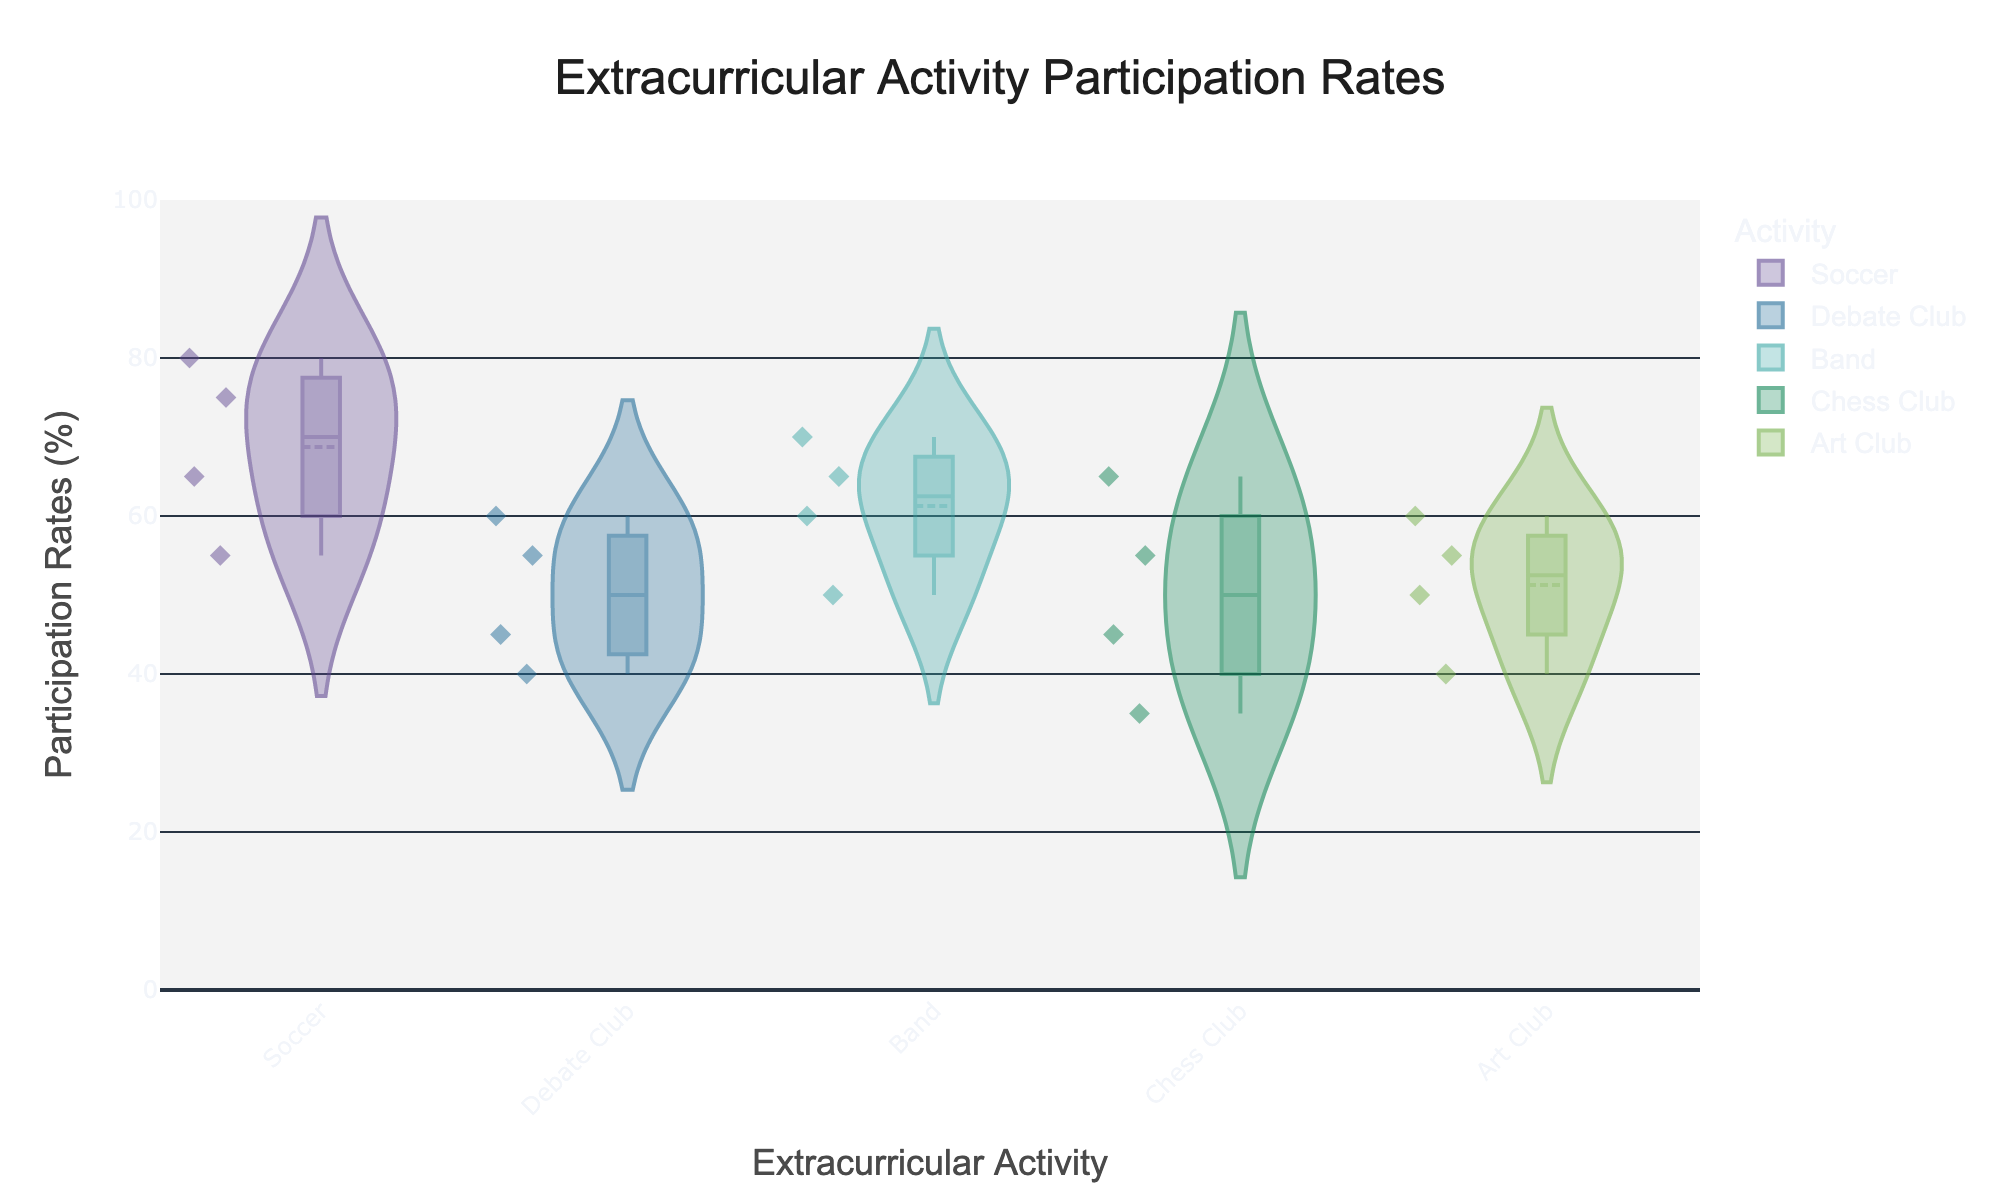What is the title of the figure? The title is usually placed at the top of the figure and is often the largest text. In this case, it reads "Extracurricular Activity Participation Rates".
Answer: Extracurricular Activity Participation Rates Which extracurricular activity has the highest participation rate for males? By looking at the plot, each extracurricular activity has a mixture of male and female participation rates. For males, the highest rate falls within the violin plot for Soccer, which has the highest point around 80%.
Answer: Soccer How do the participation rates for the Debate Club compare between males and females? The median participation rate for Debate Club males is slightly lower than for females. Males have median rates around 47.5%, while females are around 52.5%.
Answer: Females have a slightly higher median rate What is the participation rate range for the Art Club? The participation rate range can be observed by looking at the highest and lowest points on the Art Club's violin plot. The range spans from about 40% to 60%.
Answer: 40% - 60% Which extracurricular activity shows the smallest variation in participation rates? Smallest variation is inferred from the narrowest violin plot. Art Club has one of the narrowest violins, indicating the least variation.
Answer: Art Club How does the participation rate of Hispanic students in soccer compare to the overall participation rates in soccer? The overall soccer participation ranges from 55% to 80%. Hispanic students' rate is 75%, placing them towards the higher end but not the highest.
Answer: Toward the higher end What is the mean participation rate for the Band activity? The plot shows mean lines for each activity. The mean line for Band is located at approximately 61.75%.
Answer: 61.75% What extracurricular activity had the lowest participation rate recorded and what is that rate? The lowest recorded rate is observable by looking at the lowest point on any of the violin plots. Chess Club has the lowest point, which is about 35%.
Answer: 35% in Chess Club For Chess Club, how does the participation rate of females compare to that of males? Chess Club shows females have a rate of 35% and 45%, while males have rates of 55% and 65%. Males have higher rates overall.
Answer: Males have higher rates What is the median participation rate for Soccer? The median is visually represented by the thick center line in the Soccer plot. It is around 70%.
Answer: 70% 